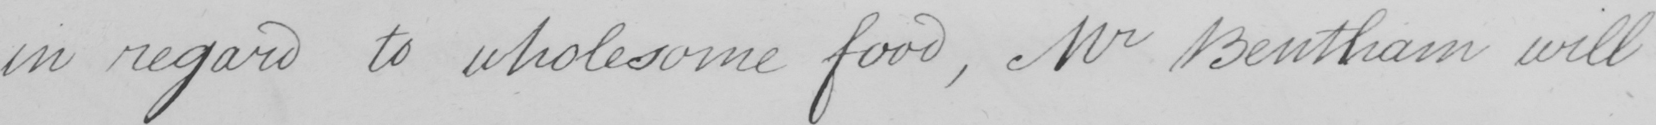What text is written in this handwritten line? in regard to wholesome food , Mr Bentham will 